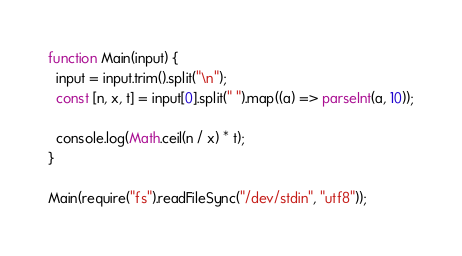<code> <loc_0><loc_0><loc_500><loc_500><_JavaScript_>function Main(input) {
  input = input.trim().split("\n");
  const [n, x, t] = input[0].split(" ").map((a) => parseInt(a, 10));

  console.log(Math.ceil(n / x) * t);
}

Main(require("fs").readFileSync("/dev/stdin", "utf8"));</code> 